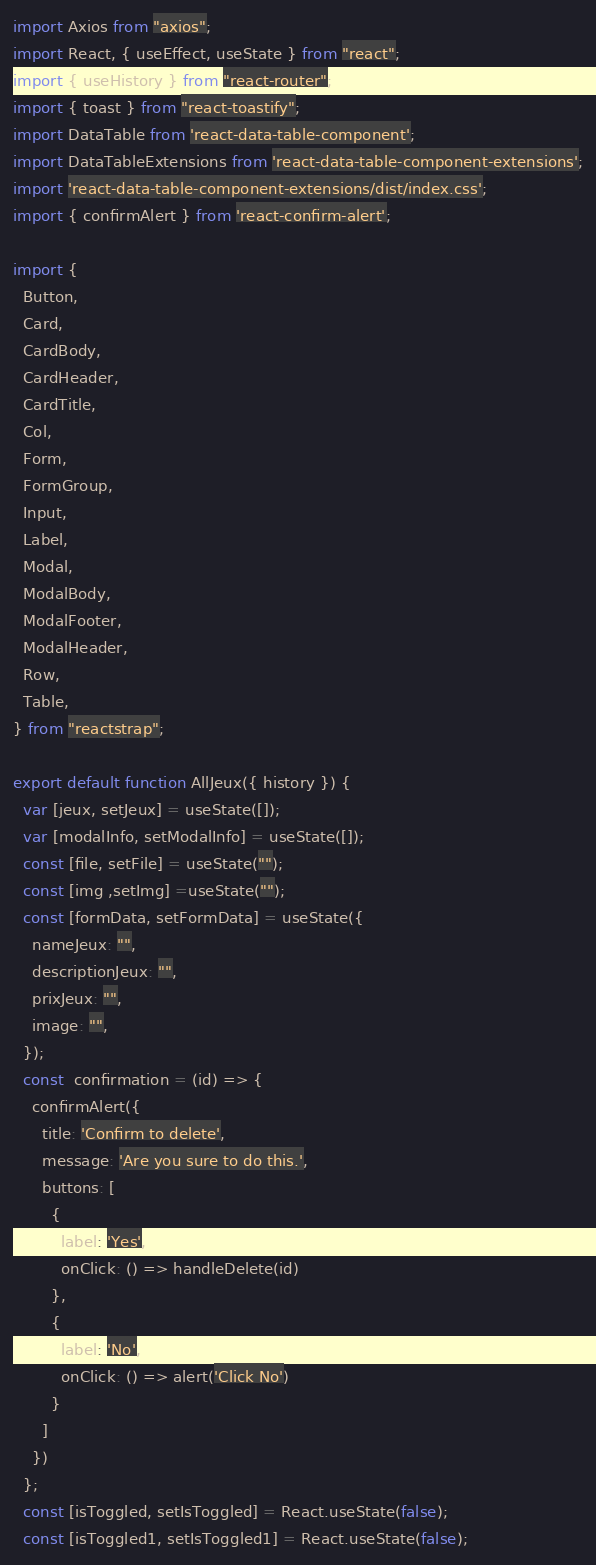Convert code to text. <code><loc_0><loc_0><loc_500><loc_500><_JavaScript_>import Axios from "axios";
import React, { useEffect, useState } from "react";
import { useHistory } from "react-router";
import { toast } from "react-toastify";
import DataTable from 'react-data-table-component';
import DataTableExtensions from 'react-data-table-component-extensions';
import 'react-data-table-component-extensions/dist/index.css';
import { confirmAlert } from 'react-confirm-alert'; 

import {
  Button,
  Card,
  CardBody,
  CardHeader,
  CardTitle,
  Col,
  Form,
  FormGroup,
  Input,
  Label,
  Modal,
  ModalBody,
  ModalFooter,
  ModalHeader,
  Row,
  Table,
} from "reactstrap";

export default function AllJeux({ history }) {
  var [jeux, setJeux] = useState([]);
  var [modalInfo, setModalInfo] = useState([]);
  const [file, setFile] = useState("");
  const [img ,setImg] =useState("");
  const [formData, setFormData] = useState({
    nameJeux: "",
    descriptionJeux: "",
    prixJeux: "",
    image: "",
  });
  const  confirmation = (id) => {
    confirmAlert({
      title: 'Confirm to delete',
      message: 'Are you sure to do this.',
      buttons: [
        {
          label: 'Yes',
          onClick: () => handleDelete(id)
        },
        {
          label: 'No',
          onClick: () => alert('Click No')
        }
      ]
    })
  };
  const [isToggled, setIsToggled] = React.useState(false);
  const [isToggled1, setIsToggled1] = React.useState(false);</code> 